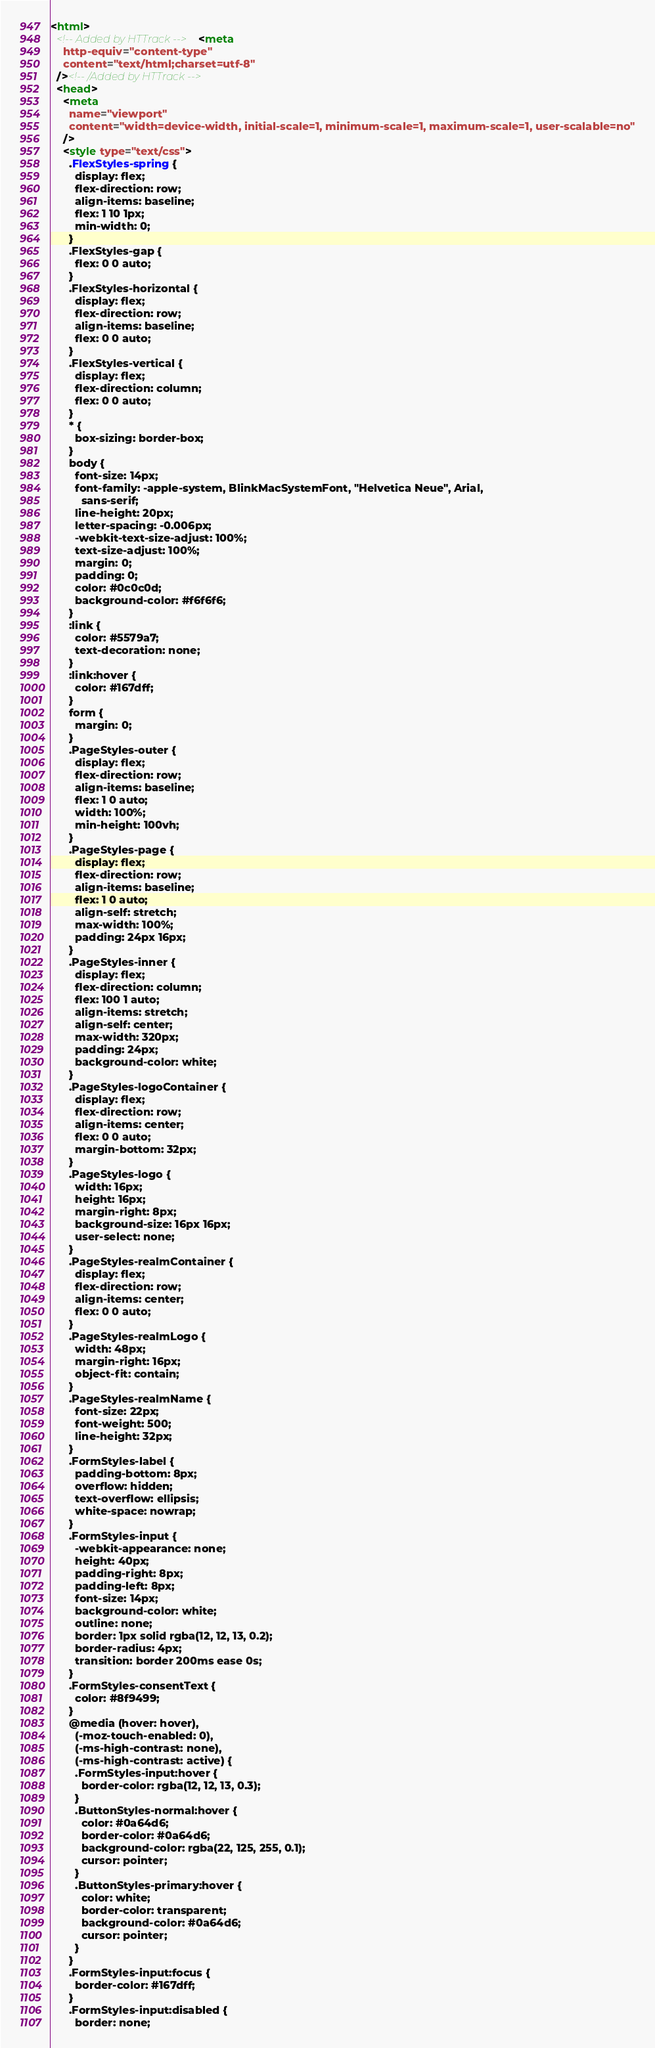<code> <loc_0><loc_0><loc_500><loc_500><_HTML_><html>
  <!-- Added by HTTrack --><meta
    http-equiv="content-type"
    content="text/html;charset=utf-8"
  /><!-- /Added by HTTrack -->
  <head>
    <meta
      name="viewport"
      content="width=device-width, initial-scale=1, minimum-scale=1, maximum-scale=1, user-scalable=no"
    />
    <style type="text/css">
      .FlexStyles-spring {
        display: flex;
        flex-direction: row;
        align-items: baseline;
        flex: 1 10 1px;
        min-width: 0;
      }
      .FlexStyles-gap {
        flex: 0 0 auto;
      }
      .FlexStyles-horizontal {
        display: flex;
        flex-direction: row;
        align-items: baseline;
        flex: 0 0 auto;
      }
      .FlexStyles-vertical {
        display: flex;
        flex-direction: column;
        flex: 0 0 auto;
      }
      * {
        box-sizing: border-box;
      }
      body {
        font-size: 14px;
        font-family: -apple-system, BlinkMacSystemFont, "Helvetica Neue", Arial,
          sans-serif;
        line-height: 20px;
        letter-spacing: -0.006px;
        -webkit-text-size-adjust: 100%;
        text-size-adjust: 100%;
        margin: 0;
        padding: 0;
        color: #0c0c0d;
        background-color: #f6f6f6;
      }
      :link {
        color: #5579a7;
        text-decoration: none;
      }
      :link:hover {
        color: #167dff;
      }
      form {
        margin: 0;
      }
      .PageStyles-outer {
        display: flex;
        flex-direction: row;
        align-items: baseline;
        flex: 1 0 auto;
        width: 100%;
        min-height: 100vh;
      }
      .PageStyles-page {
        display: flex;
        flex-direction: row;
        align-items: baseline;
        flex: 1 0 auto;
        align-self: stretch;
        max-width: 100%;
        padding: 24px 16px;
      }
      .PageStyles-inner {
        display: flex;
        flex-direction: column;
        flex: 100 1 auto;
        align-items: stretch;
        align-self: center;
        max-width: 320px;
        padding: 24px;
        background-color: white;
      }
      .PageStyles-logoContainer {
        display: flex;
        flex-direction: row;
        align-items: center;
        flex: 0 0 auto;
        margin-bottom: 32px;
      }
      .PageStyles-logo {
        width: 16px;
        height: 16px;
        margin-right: 8px;
        background-size: 16px 16px;
        user-select: none;
      }
      .PageStyles-realmContainer {
        display: flex;
        flex-direction: row;
        align-items: center;
        flex: 0 0 auto;
      }
      .PageStyles-realmLogo {
        width: 48px;
        margin-right: 16px;
        object-fit: contain;
      }
      .PageStyles-realmName {
        font-size: 22px;
        font-weight: 500;
        line-height: 32px;
      }
      .FormStyles-label {
        padding-bottom: 8px;
        overflow: hidden;
        text-overflow: ellipsis;
        white-space: nowrap;
      }
      .FormStyles-input {
        -webkit-appearance: none;
        height: 40px;
        padding-right: 8px;
        padding-left: 8px;
        font-size: 14px;
        background-color: white;
        outline: none;
        border: 1px solid rgba(12, 12, 13, 0.2);
        border-radius: 4px;
        transition: border 200ms ease 0s;
      }
      .FormStyles-consentText {
        color: #8f9499;
      }
      @media (hover: hover),
        (-moz-touch-enabled: 0),
        (-ms-high-contrast: none),
        (-ms-high-contrast: active) {
        .FormStyles-input:hover {
          border-color: rgba(12, 12, 13, 0.3);
        }
        .ButtonStyles-normal:hover {
          color: #0a64d6;
          border-color: #0a64d6;
          background-color: rgba(22, 125, 255, 0.1);
          cursor: pointer;
        }
        .ButtonStyles-primary:hover {
          color: white;
          border-color: transparent;
          background-color: #0a64d6;
          cursor: pointer;
        }
      }
      .FormStyles-input:focus {
        border-color: #167dff;
      }
      .FormStyles-input:disabled {
        border: none;</code> 